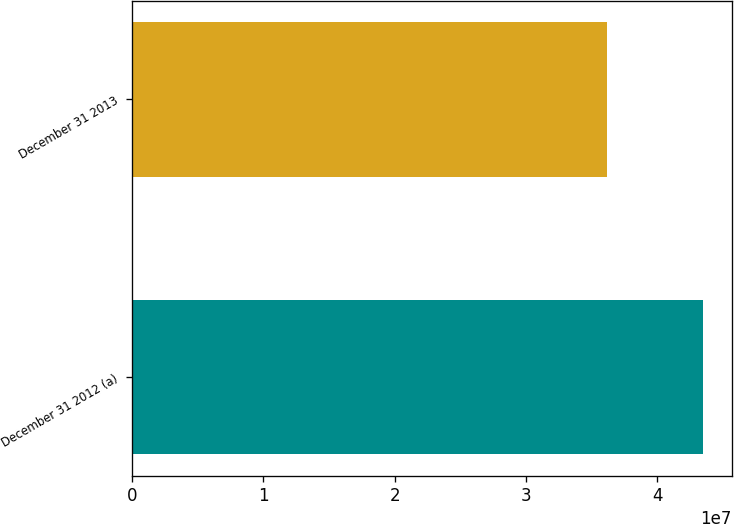Convert chart to OTSL. <chart><loc_0><loc_0><loc_500><loc_500><bar_chart><fcel>December 31 2012 (a)<fcel>December 31 2013<nl><fcel>4.35117e+07<fcel>3.6185e+07<nl></chart> 